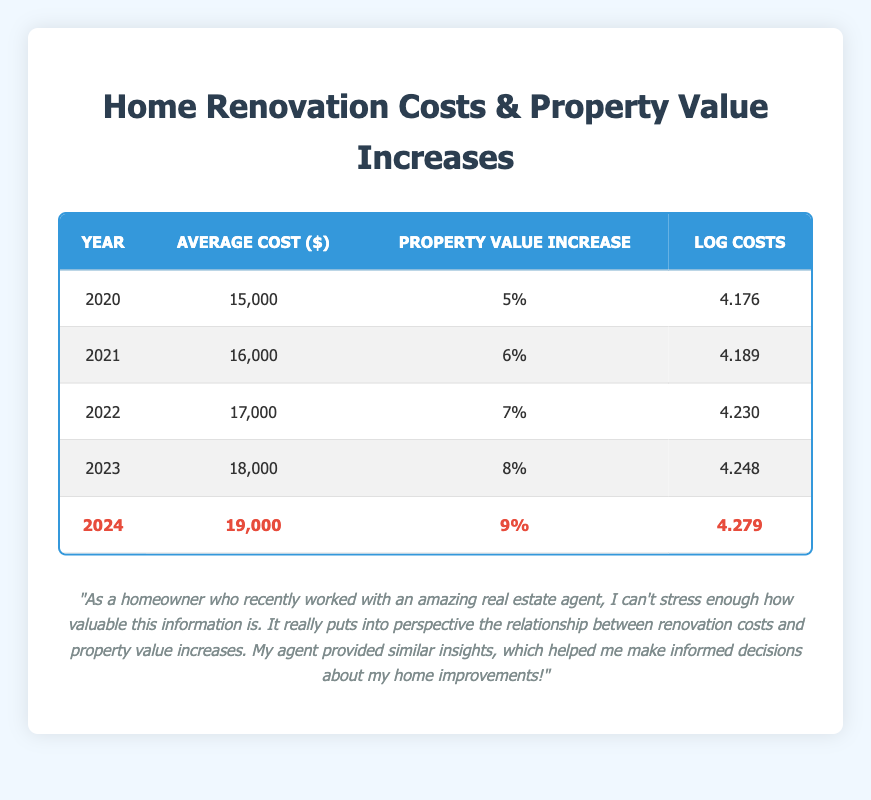What was the average cost of home renovations in 2022? The table shows that the average cost of home renovations for the year 2022 is listed in the corresponding row. The value is $17,000.
Answer: 17,000 In which year was the property value increase the highest? By looking at the property value increase column, the highest increase is 9%, which corresponds to the year 2024.
Answer: 2024 What is the average property value increase from 2020 to 2024? The property value increases for the years 2020 to 2024 are 5%, 6%, 7%, 8%, and 9%. First, sum these values: 5 + 6 + 7 + 8 + 9 = 35. Then divide by the number of years (5) to find the average: 35/5 = 7%.
Answer: 7% Was the average renovation cost in 2023 higher than in 2021? The average renovation cost for 2023 is $18,000 while for 2021 it is $16,000. Since 18,000 is greater than 16,000, the statement is true.
Answer: Yes If we compare the log costs between 2020 and 2024, what is the difference? The log cost for 2020 is 4.176 and for 2024 it is 4.279. To find the difference, subtract the 2020 value from the 2024 value: 4.279 - 4.176 = 0.103.
Answer: 0.103 In which year did the average cost first exceed $17,000? The average cost first exceeds $17,000 in the year 2022 when the average cost is $17,000. However, exceeding means any value greater than $17,000, which occurs in 2023 at $18,000.
Answer: 2023 What was the average log cost for the years 2021 and 2022 combined? The log costs for 2021 and 2022 are 4.189 and 4.230, respectively. First, sum these values: 4.189 + 4.230 = 8.419. Then divide by 2 to find the average: 8.419/2 = 4.2095.
Answer: 4.2095 Is there a year where the average cost was exactly $18,000? Yes, by looking at the average cost column, the year 2023 shows an average cost of $18,000.
Answer: Yes What is the trend of average renovations costs from 2020 to 2024? The average renovation costs are increasing each year: from $15,000 in 2020 to $19,000 in 2024. This indicates a consistent upward trend in renovation costs over these years.
Answer: Upward trend 